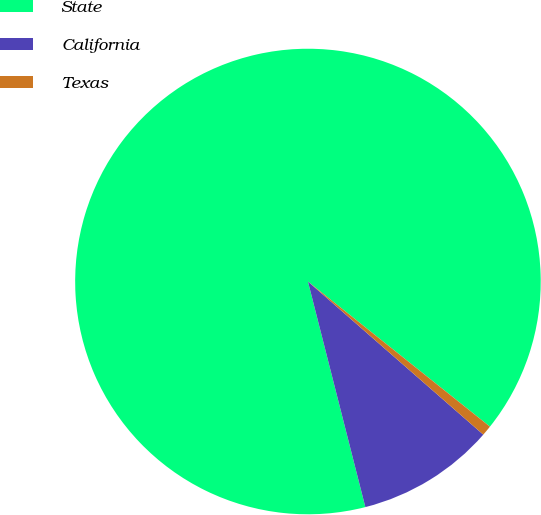<chart> <loc_0><loc_0><loc_500><loc_500><pie_chart><fcel>State<fcel>California<fcel>Texas<nl><fcel>89.68%<fcel>9.61%<fcel>0.71%<nl></chart> 